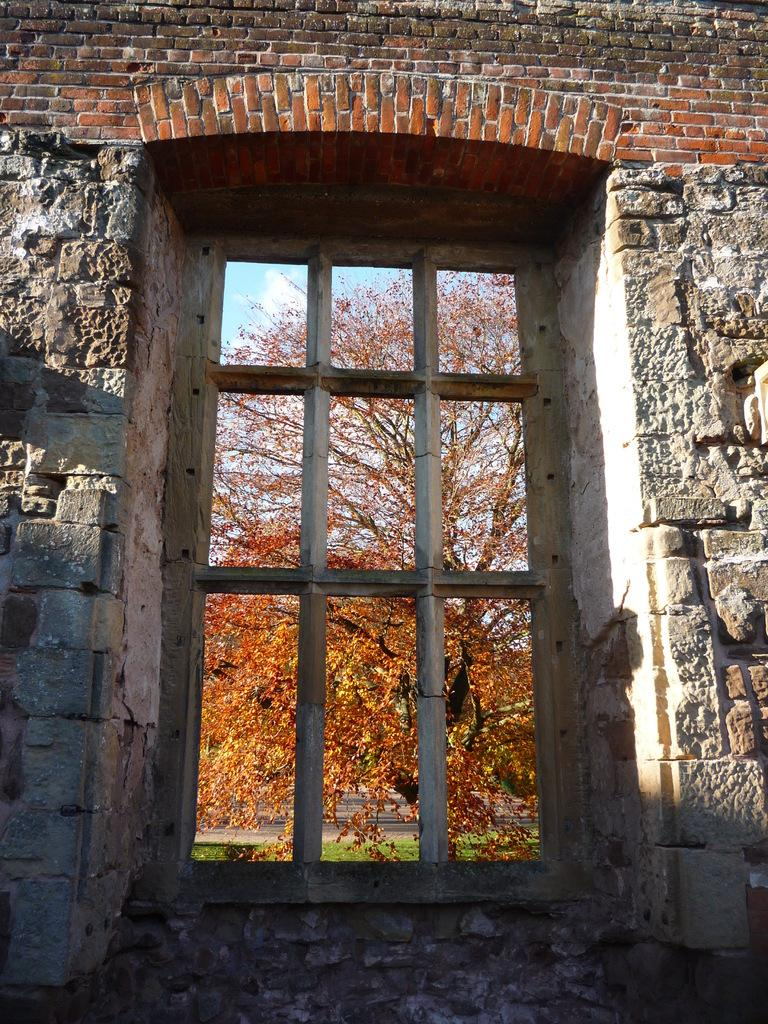What is a prominent feature of the image? There is a wall in the image. What is a notable detail about the wall? There is a window in the wall. What can be seen through the window? A tree is visible through the window. What type of vegetation is present at the bottom of the image? Green grass is present at the bottom of the image. How many dolls are sitting on the arm of the chair in the image? There are no dolls or chairs present in the image. 